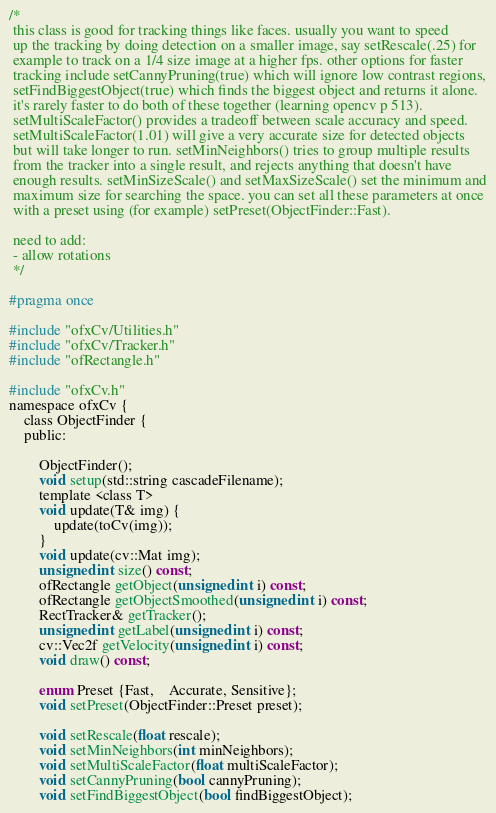<code> <loc_0><loc_0><loc_500><loc_500><_C_>/* 
 this class is good for tracking things like faces. usually you want to speed
 up the tracking by doing detection on a smaller image, say setRescale(.25) for
 example to track on a 1/4 size image at a higher fps. other options for faster
 tracking include setCannyPruning(true) which will ignore low contrast regions,
 setFindBiggestObject(true) which finds the biggest object and returns it alone.
 it's rarely faster to do both of these together (learning opencv p 513).
 setMultiScaleFactor() provides a tradeoff between scale accuracy and speed.
 setMultiScaleFactor(1.01) will give a very accurate size for detected objects
 but will take longer to run. setMinNeighbors() tries to group multiple results
 from the tracker into a single result, and rejects anything that doesn't have
 enough results. setMinSizeScale() and setMaxSizeScale() set the minimum and
 maximum size for searching the space. you can set all these parameters at once
 with a preset using (for example) setPreset(ObjectFinder::Fast).
 
 need to add:
 - allow rotations
 */

#pragma once

#include "ofxCv/Utilities.h"
#include "ofxCv/Tracker.h"
#include "ofRectangle.h"

#include "ofxCv.h"
namespace ofxCv {
	class ObjectFinder {
	public:
		
		ObjectFinder();
		void setup(std::string cascadeFilename);
		template <class T> 
		void update(T& img) {
			update(toCv(img));
		}
		void update(cv::Mat img);
        unsigned int size() const;
		ofRectangle getObject(unsigned int i) const;
		ofRectangle getObjectSmoothed(unsigned int i) const;
		RectTracker& getTracker();
		unsigned int getLabel(unsigned int i) const;
		cv::Vec2f getVelocity(unsigned int i) const;
		void draw() const;
		
		enum Preset {Fast,	Accurate, Sensitive};
		void setPreset(ObjectFinder::Preset preset);
		
		void setRescale(float rescale);
		void setMinNeighbors(int minNeighbors);
		void setMultiScaleFactor(float multiScaleFactor);
		void setCannyPruning(bool cannyPruning);
		void setFindBiggestObject(bool findBiggestObject);</code> 